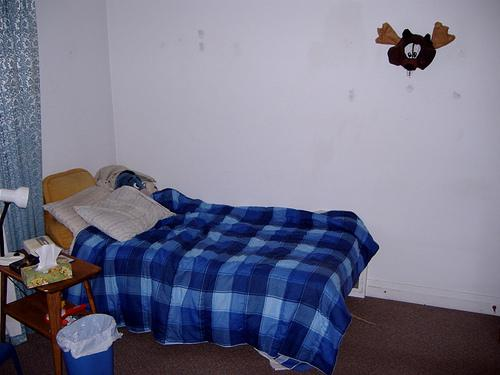Question: what is shown in the picture?
Choices:
A. A back yard.
B. A bathroom.
C. A bedroom.
D. A cute house.
Answer with the letter. Answer: C Question: what is the color of the bedspread?
Choices:
A. Blue.
B. Yellow.
C. Pink.
D. Orange.
Answer with the letter. Answer: A Question: who is laying in the bed?
Choices:
A. A stuffed animal.
B. The twins.
C. A girl.
D. A boy.
Answer with the letter. Answer: A 